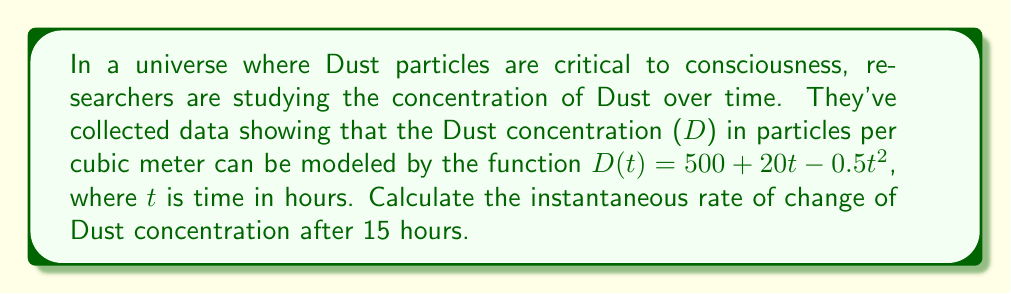Provide a solution to this math problem. To find the instantaneous rate of change, we need to calculate the derivative of the function D(t) and then evaluate it at t = 15.

1. Given function: $D(t) = 500 + 20t - 0.5t^2$

2. Calculate the derivative:
   $\frac{d}{dt}D(t) = \frac{d}{dt}(500) + \frac{d}{dt}(20t) - \frac{d}{dt}(0.5t^2)$
   $D'(t) = 0 + 20 - 0.5(2t)$
   $D'(t) = 20 - t$

3. Evaluate the derivative at t = 15:
   $D'(15) = 20 - 15 = 5$

The instantaneous rate of change after 15 hours is 5 particles per cubic meter per hour.
Answer: $5$ particles/m³/hour 